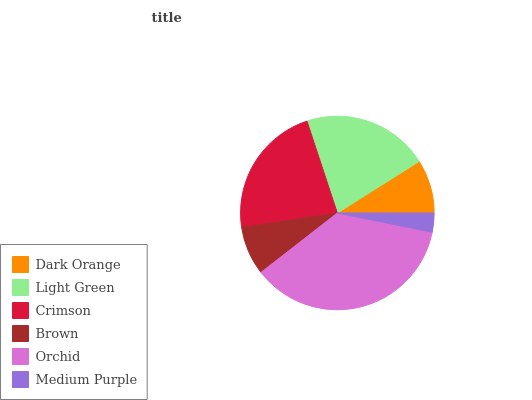Is Medium Purple the minimum?
Answer yes or no. Yes. Is Orchid the maximum?
Answer yes or no. Yes. Is Light Green the minimum?
Answer yes or no. No. Is Light Green the maximum?
Answer yes or no. No. Is Light Green greater than Dark Orange?
Answer yes or no. Yes. Is Dark Orange less than Light Green?
Answer yes or no. Yes. Is Dark Orange greater than Light Green?
Answer yes or no. No. Is Light Green less than Dark Orange?
Answer yes or no. No. Is Light Green the high median?
Answer yes or no. Yes. Is Dark Orange the low median?
Answer yes or no. Yes. Is Brown the high median?
Answer yes or no. No. Is Crimson the low median?
Answer yes or no. No. 